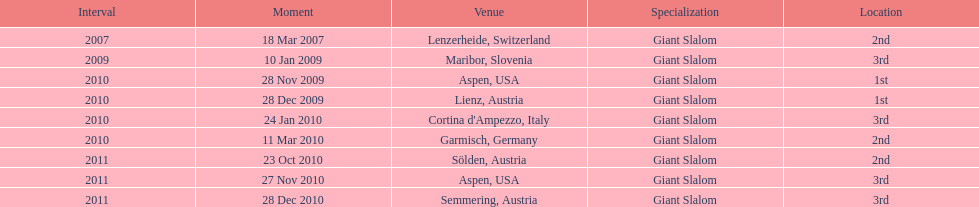Aspen and lienz in 2009 are the only races where this racer got what position? 1st. 